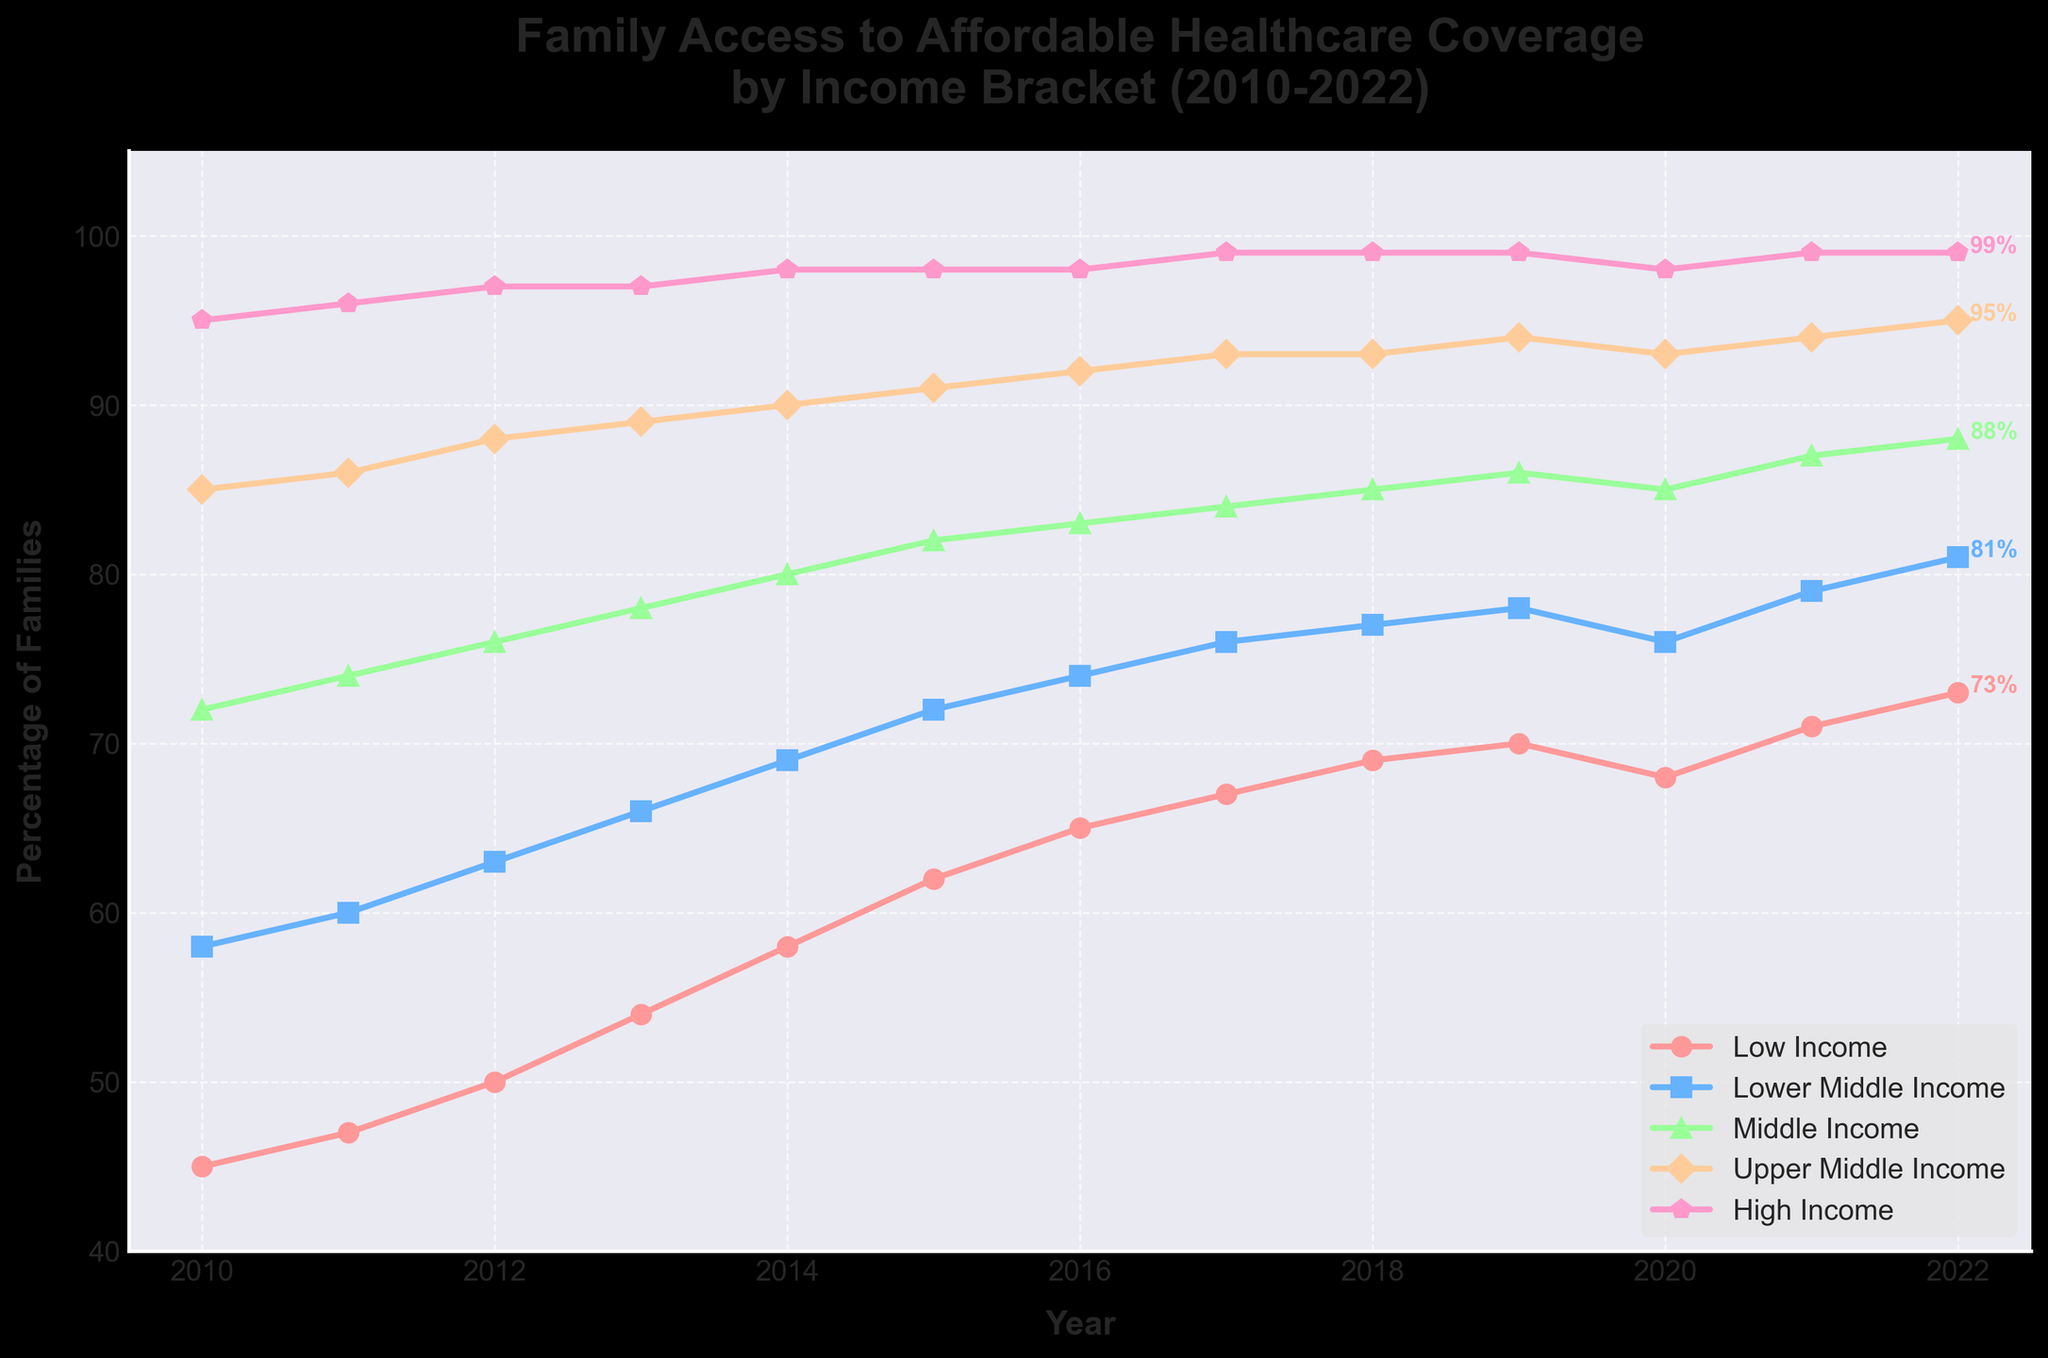Which income bracket had the highest percentage of families with access to affordable healthcare coverage in 2010? Looking at the chart, the high-income bracket had the highest percentage in 2010 with 95%.
Answer: High-income How did the percentage of families with access to affordable healthcare coverage change for the middle-income bracket from 2010 to 2022? In 2010, the percentage was 72%, and in 2022, it was 88%. The change is 88% - 72% = 16%.
Answer: Increased by 16% In which year did the low-income bracket reach a 70% access rate to affordable healthcare coverage? By observing the low-income line, it reached 70% in the year 2019.
Answer: 2019 Which income bracket saw the most substantial increase in access to affordable healthcare coverage over the period depicted in the chart? Comparing the increases: Low Income (28%), Lower Middle Income (23%), Middle Income (16%), Upper Middle Income (10%), High Income (4%). The low-income bracket saw the most substantial increase.
Answer: Low-income What is the difference between the percentages of low-income and high-income families with access to affordable healthcare coverage in 2022? In 2022, the high-income percentage was 99% and the low-income percentage was 73%. The difference is 99% - 73% = 26%.
Answer: 26% Which two income brackets had the closest percentage of families' access to affordable healthcare coverage in 2020, and what is the difference between them? In 2020, Lower Middle Income (76%) and Middle Income (85%) were closest. The difference is 85% - 76% = 9%.
Answer: Lower Middle Income and Middle Income; 9% If the upward trend continues, what could be the projected percentage of upper middle-income families with access in 2024? From 2010 to 2022, it increased from 85% to 95%, a 10% increase over 12 years, roughly 0.83% per year. Extrapolating 2 more years: 95% + (2 * 0.83%) = 96.66%.
Answer: Approximately 97% By what percentage did the lower middle-income bracket improve its access from 2016 to 2022? In 2016, it was 74%, and in 2022, it was 81%. The improvement is 81% - 74% = 7%.
Answer: 7% What's the average percentage of families with access to affordable healthcare coverage in the middle-income bracket from 2010 to 2022? The percentages are 72, 74, 76, 78, 80, 82, 83, 84, 85, 85, 85, 87, 88, summing to 1059. The average is 1059 / 13 ≈ 81.46%.
Answer: Approximately 81.46% 